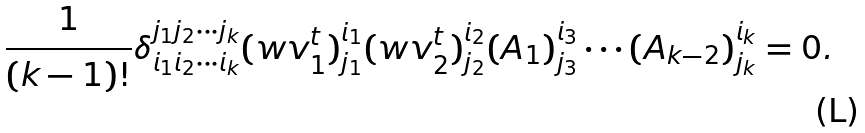Convert formula to latex. <formula><loc_0><loc_0><loc_500><loc_500>\frac { 1 } { ( k - 1 ) ! } \delta _ { i _ { 1 } i _ { 2 } \cdots i _ { k } } ^ { j _ { 1 } j _ { 2 } \cdots j _ { k } } ( w v _ { 1 } ^ { t } ) ^ { i _ { 1 } } _ { j _ { 1 } } ( w v _ { 2 } ^ { t } ) ^ { i _ { 2 } } _ { j _ { 2 } } ( A _ { 1 } ) ^ { i _ { 3 } } _ { j _ { 3 } } \cdots ( A _ { k - 2 } ) ^ { i _ { k } } _ { j _ { k } } = 0 .</formula> 